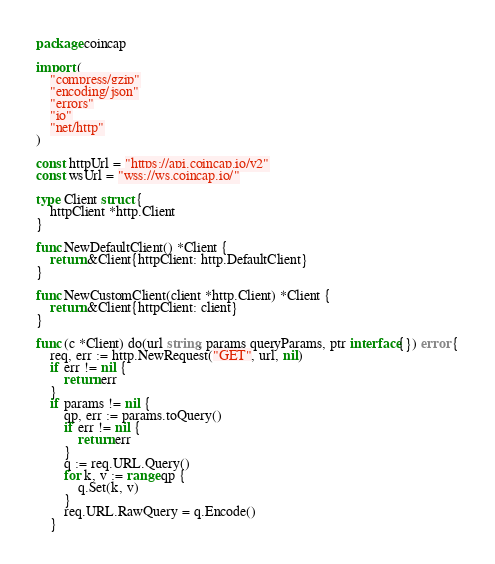<code> <loc_0><loc_0><loc_500><loc_500><_Go_>package coincap

import (
	"compress/gzip"
	"encoding/json"
	"errors"
	"io"
	"net/http"
)

const httpUrl = "https://api.coincap.io/v2"
const wsUrl = "wss://ws.coincap.io/"

type Client struct {
	httpClient *http.Client
}

func NewDefaultClient() *Client {
	return &Client{httpClient: http.DefaultClient}
}

func NewCustomClient(client *http.Client) *Client {
	return &Client{httpClient: client}
}

func (c *Client) do(url string, params queryParams, ptr interface{}) error {
	req, err := http.NewRequest("GET", url, nil)
	if err != nil {
		return err
	}
	if params != nil {
		qp, err := params.toQuery()
		if err != nil {
			return err
		}
		q := req.URL.Query()
		for k, v := range qp {
			q.Set(k, v)
		}
		req.URL.RawQuery = q.Encode()
	}</code> 